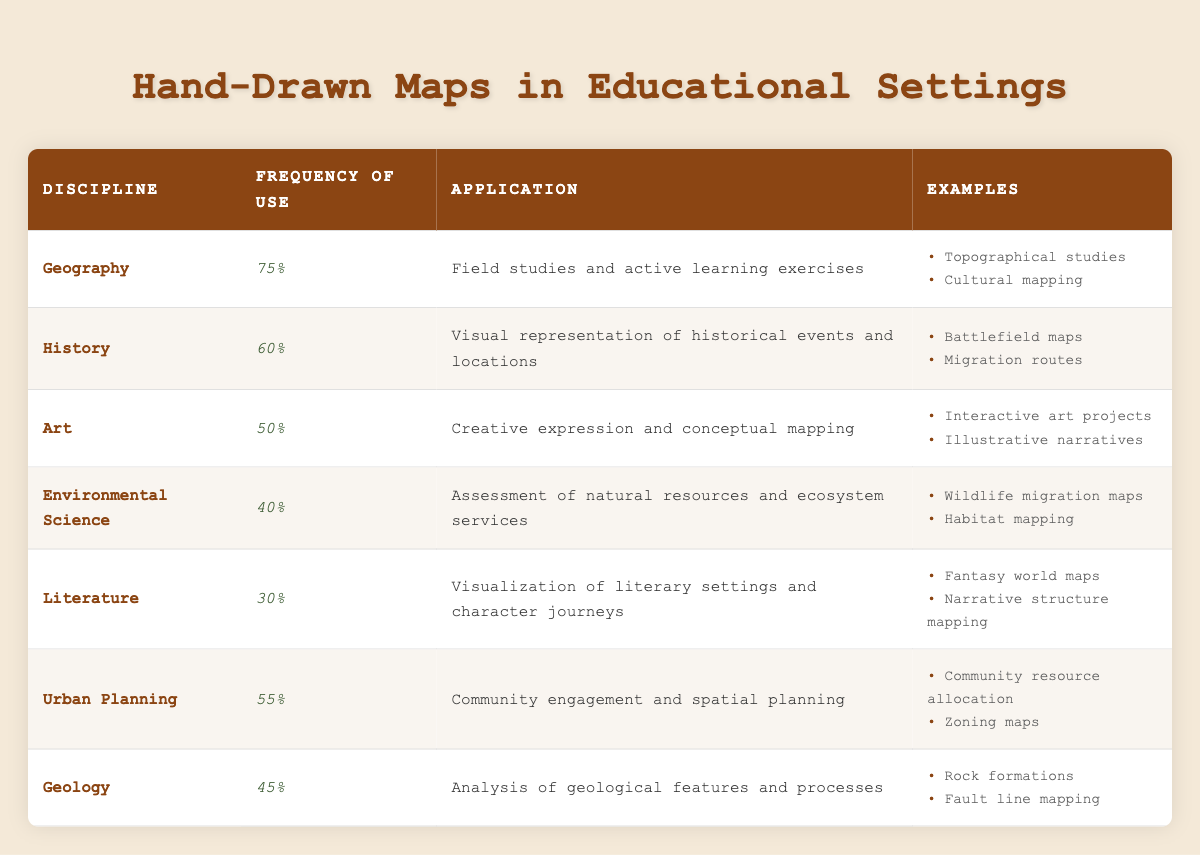What is the frequency of use for hand-drawn maps in the Geography discipline? The table shows that the frequency of use in Geography is listed directly as 75% in the respective row.
Answer: 75% Which discipline has the highest frequency of use for hand-drawn maps? By reviewing the table, Geography has the highest frequency of use at 75%, compared to other disciplines listed.
Answer: Geography Is hand-drawn map usage in Literature higher than in Environmental Science? The frequency of use for Literature is 30%, while for Environmental Science it is 40%. Since 30% is less than 40%, the statement is false.
Answer: No What are two applications of hand-drawn maps in Urban Planning? The Urban Planning row specifies that the applications are community engagement and spatial planning.
Answer: Community engagement and spatial planning What is the average frequency of use across all disciplines listed in the table? To find the average, sum the frequencies: 75 + 60 + 50 + 40 + 30 + 55 + 45 = 355. There are 7 disciplines, so the average is 355 / 7 = 50.71%, rounding to two decimal places gives approximately 50.71%.
Answer: 50.71% In which discipline is hand-drawn maps usage at 40% and what is the primary application? The table indicates that the frequency of use at 40% corresponds to Environmental Science, with the application being assessment of natural resources and ecosystem services.
Answer: Environmental Science; assessment of natural resources and ecosystem services Are there any disciplines where the application involves creative expression? The Art discipline explicitly mentions creative expression in its application, so yes, there is at least one discipline with this application.
Answer: Yes How would you compare the frequency of use between Geology and History? Geology has a frequency of use at 45%, while History is at 60%. Since 60% is greater than 45%, History has a higher frequency of use than Geology.
Answer: History has a higher frequency of use 